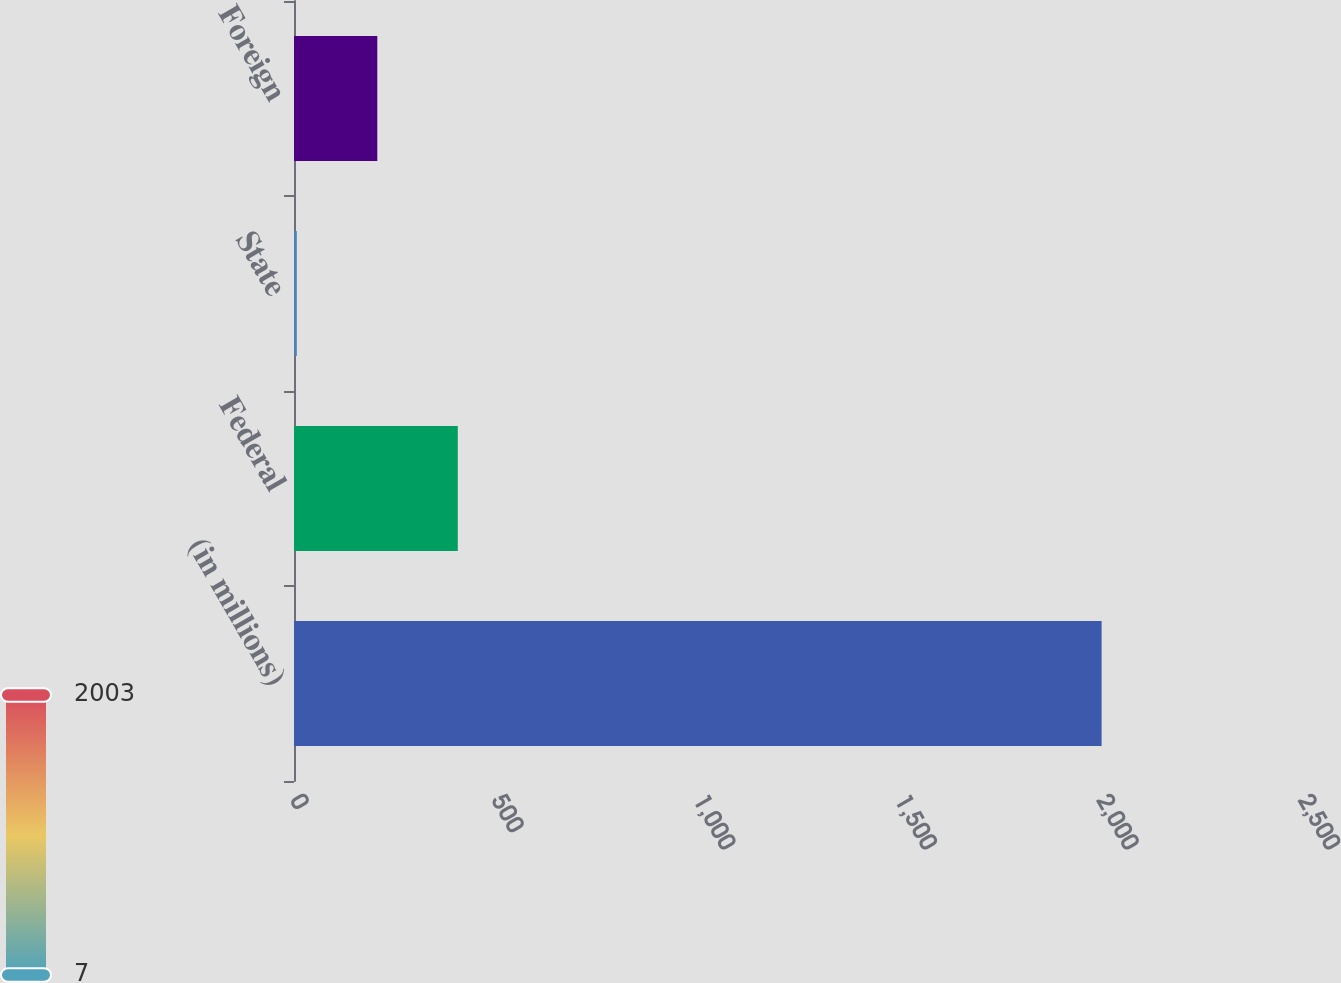<chart> <loc_0><loc_0><loc_500><loc_500><bar_chart><fcel>(in millions)<fcel>Federal<fcel>State<fcel>Foreign<nl><fcel>2003<fcel>406.2<fcel>7<fcel>206.6<nl></chart> 